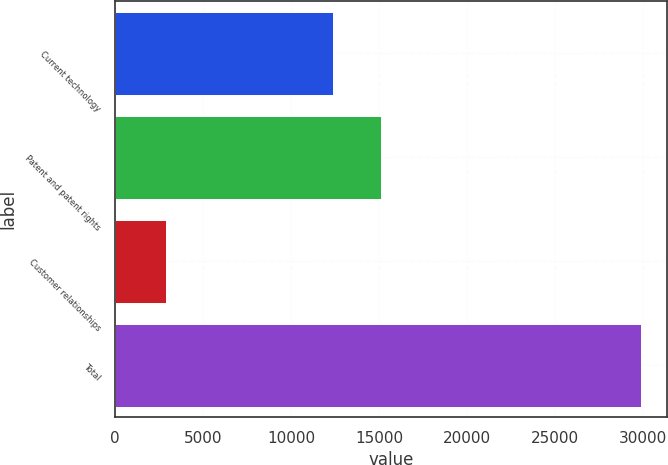Convert chart to OTSL. <chart><loc_0><loc_0><loc_500><loc_500><bar_chart><fcel>Current technology<fcel>Patent and patent rights<fcel>Customer relationships<fcel>Total<nl><fcel>12391<fcel>15091.9<fcel>2880<fcel>29889<nl></chart> 